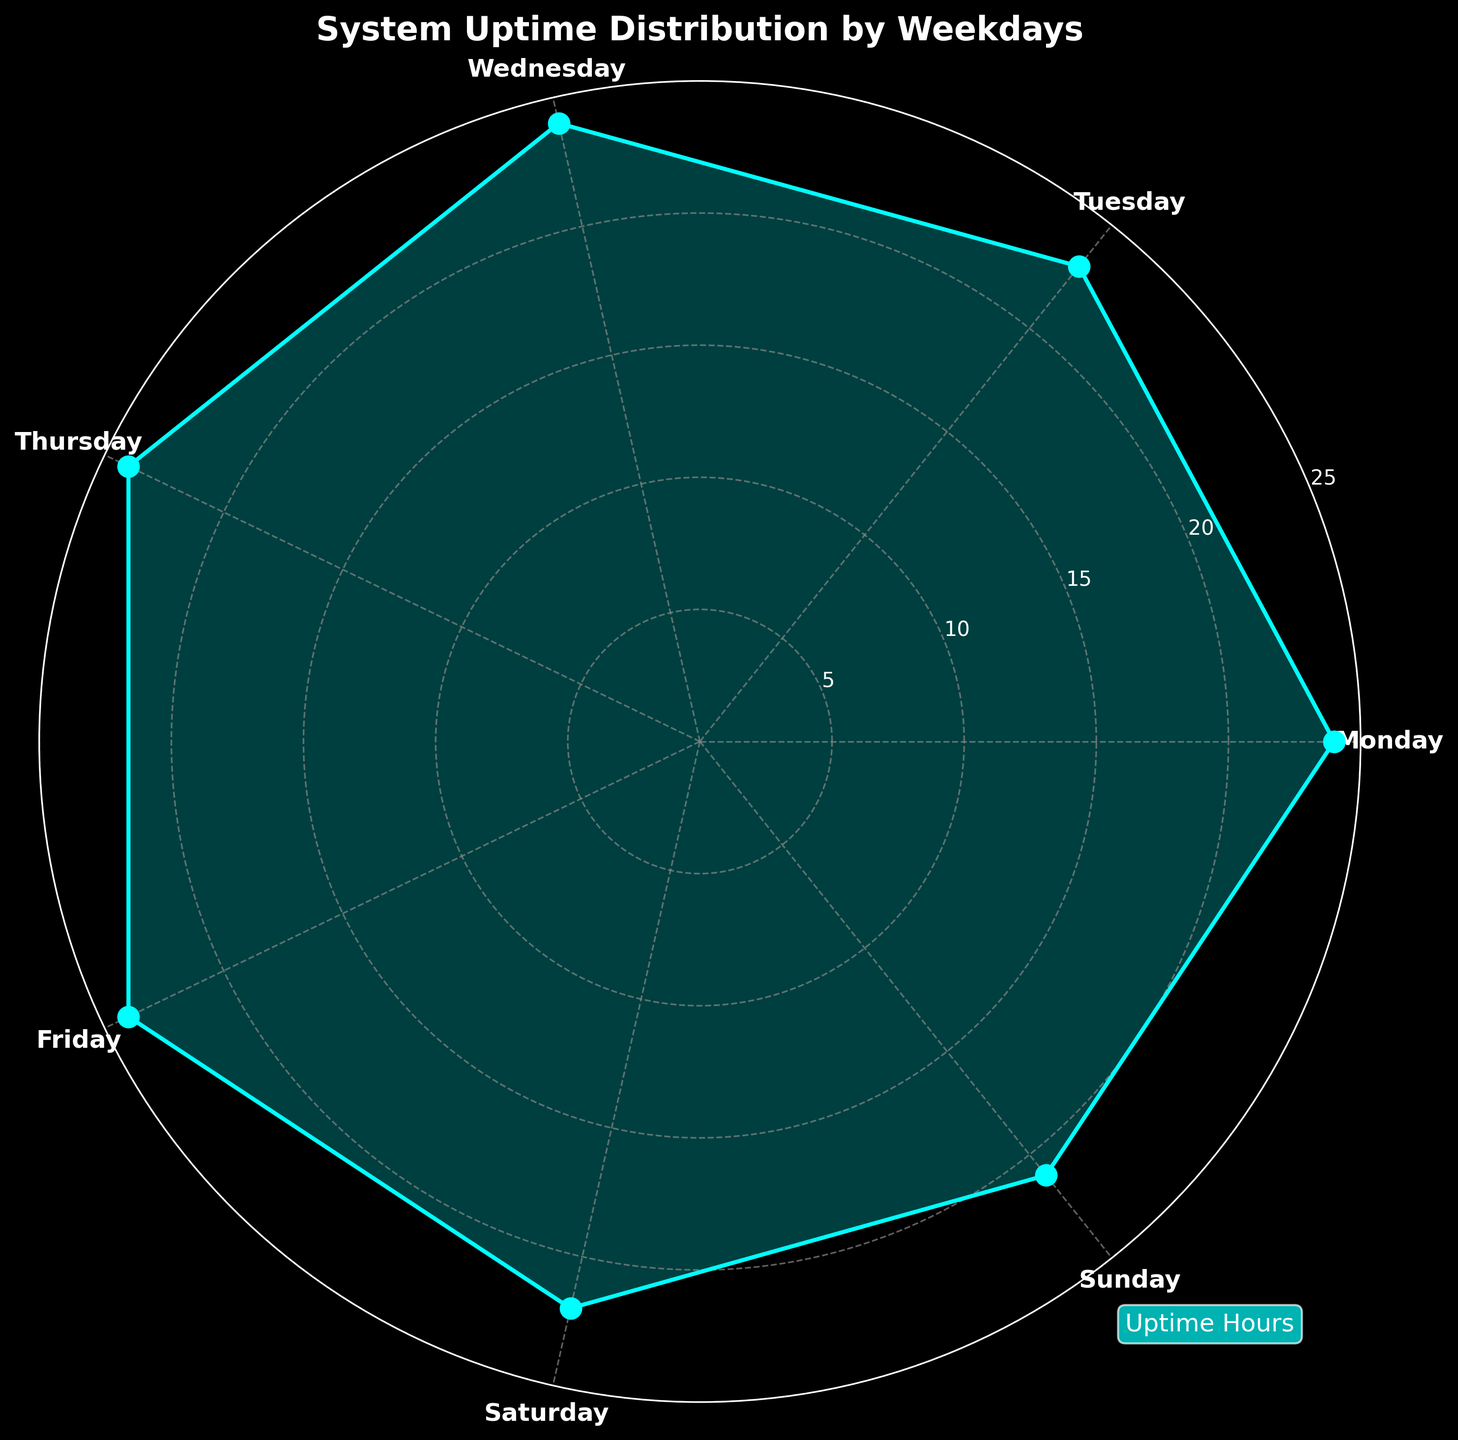What is the title of the chart? The title is usually located at the top of the figure, and it indicates what the chart is about. Here, the title clearly states the data being visualized.
Answer: System Uptime Distribution by Weekdays How many distinct weekdays are shown in this chart? By counting the labels on the angular axis, it's evident that the chart includes data for each day of the week.
Answer: 7 On which day is the uptime the highest? By observing the radial distance from the center for each weekday, the maximum value is noted at a specific point. Monday, Wednesday, Thursday, and Friday all reach the outermost circle.
Answer: Monday, Wednesday, Thursday, and Friday Which day has the lowest uptime? By locating the point closest to the center, we can determine the weekday with the lowest value on the radial scale.
Answer: Sunday What is the uptime for Tuesday? The radial position of Tuesday's point indicates its uptime, which can be read directly from the chart.
Answer: 23 hours Compare the uptime on Saturday and Sunday. Which is greater? By identifying the points corresponding to Saturday and Sunday, it's clear which is further from the center, indicating a higher uptime.
Answer: Saturday What is the average uptime during weekdays? Adding the uptime values for Monday through Friday and then dividing by 5 will give the average. (24 + 23 + 24 + 24 + 24) / 5 = 23.8
Answer: 23.8 hours What's the difference in uptime between the day with the maximum value and the day with the minimum value? Subtract the minimal value (Sunday) from the maximal value (Monday, Wednesday, Thursday, Friday). 24 - 21 = 3 hours.
Answer: 3 hours How many days have an uptime of 24 hours? By counting the points that are on the outermost circle (24 hours), we can determine how many days have the maximum uptime.
Answer: 4 What is the total uptime across the entire week? Summing up all individual uptimes will give the total uptime for the week. 24 + 23 + 24 + 24 + 24 + 22 + 21 = 162 hours
Answer: 162 hours 